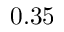<formula> <loc_0><loc_0><loc_500><loc_500>0 . 3 5</formula> 